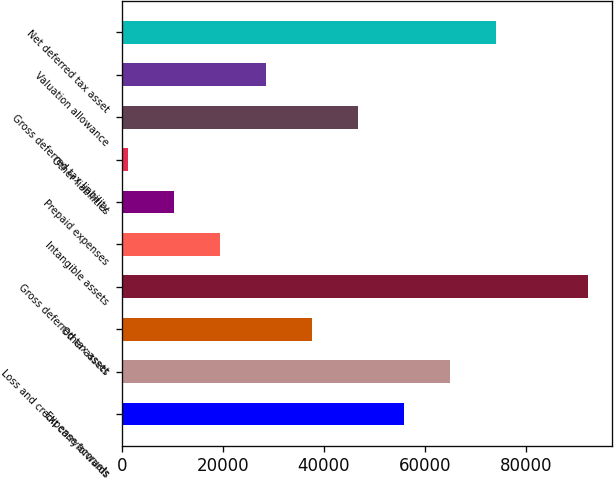Convert chart to OTSL. <chart><loc_0><loc_0><loc_500><loc_500><bar_chart><fcel>Expense accruals<fcel>Loss and credit carryforwards<fcel>Other assets<fcel>Gross deferred tax asset<fcel>Intangible assets<fcel>Prepaid expenses<fcel>Other liabilities<fcel>Gross deferred tax liability<fcel>Valuation allowance<fcel>Net deferred tax asset<nl><fcel>55950.2<fcel>65076.9<fcel>37696.8<fcel>92457<fcel>19443.4<fcel>10316.7<fcel>1190<fcel>46823.5<fcel>28570.1<fcel>74203.6<nl></chart> 